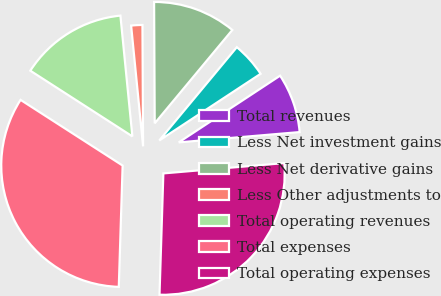Convert chart. <chart><loc_0><loc_0><loc_500><loc_500><pie_chart><fcel>Total revenues<fcel>Less Net investment gains<fcel>Less Net derivative gains<fcel>Less Other adjustments to<fcel>Total operating revenues<fcel>Total expenses<fcel>Total operating expenses<nl><fcel>7.91%<fcel>4.7%<fcel>11.12%<fcel>1.49%<fcel>14.33%<fcel>33.6%<fcel>26.86%<nl></chart> 